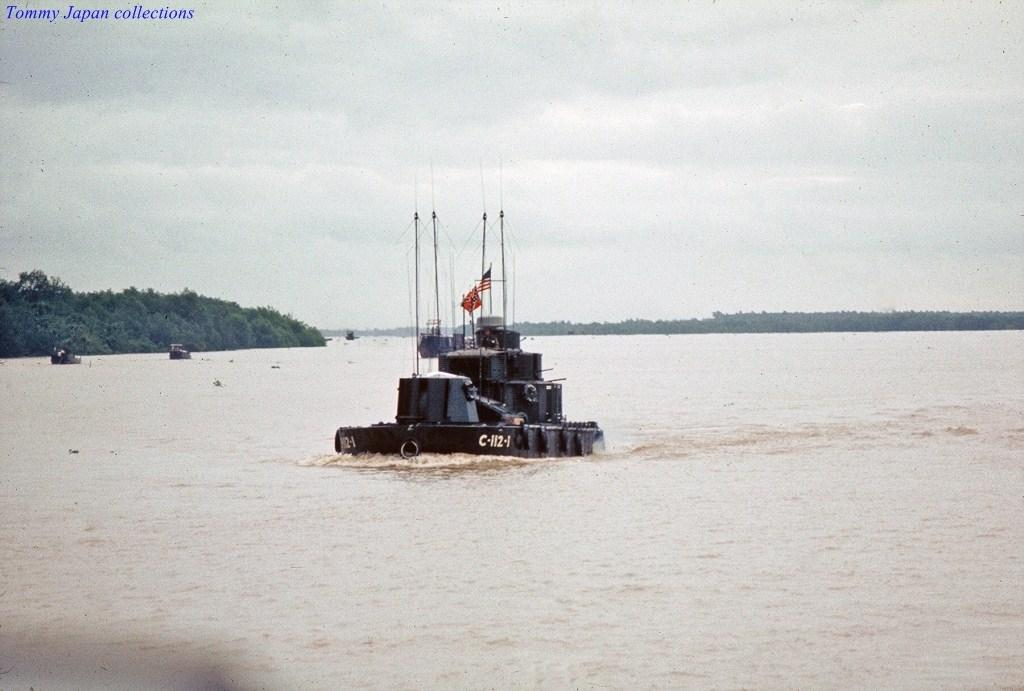<image>
Share a concise interpretation of the image provided. A boat that says C-112-1 on it, the photo says Timmy Japan collections. 